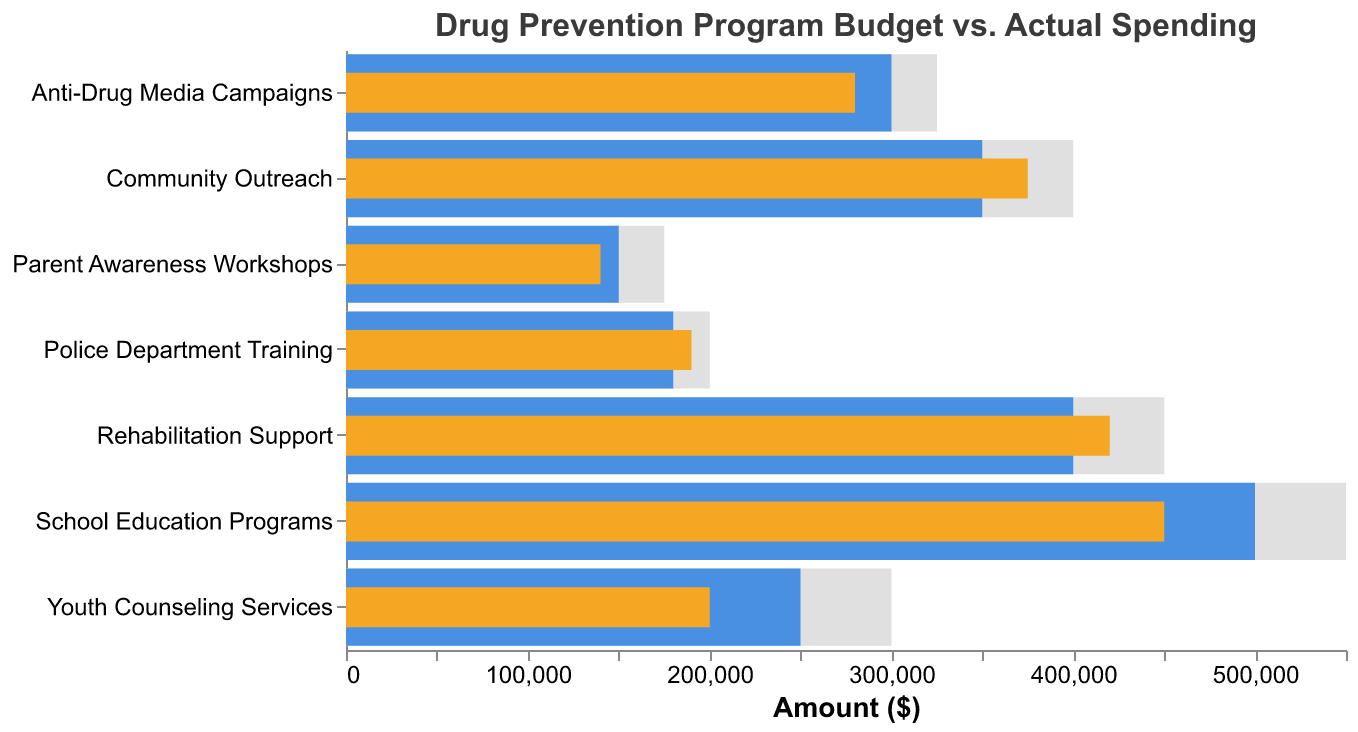How many initiatives are listed in the figure? There are a total of 7 categories listed in the data and each represents an initiative. You can count the different rows or categories along the y-axis.
Answer: 7 What is the title of the figure? The title is displayed at the top of the chart.
Answer: Drug Prevention Program Budget vs. Actual Spending Which initiative had the highest budgeted amount? The initiative with the highest budgeted amount among the listed categories is identified by looking at the "Budgeted ($)" bars for the largest value.
Answer: School Education Programs Did the Youth Counseling Services meet its target spending? To determine if the target was met, compare the actual spending amount to the target amount. For Youth Counseling Services, the actual spending is 200,000, and the target is 300,000, so the target was not met.
Answer: No Which initiative had actual spending that exceeded its budgeted amount? To find this, compare the actual spending bars to the budgeted bars for each initiative. Rehabilitation Support had actual spending of 420,000 compared to a budgeted amount of 400,000.
Answer: Rehabilitation Support What was the difference between budgeted and actual spending for Anti-Drug Media Campaigns? Subtract the actual spending from the budgeted amount for Anti-Drug Media Campaigns: 300,000 - 280,000 = 20,000.
Answer: 20,000 Which initiative had the largest gap between its budgeted and target spending? Calculate the difference between budgeted and target spending for each initiative and find the one with the largest gap. School Education Programs: 550,000 - 500,000 = 50,000.
Answer: School Education Programs Which initiative's actual spending most closely matched its target? Compare the actual spending to the target amount for each initiative and find the closest match. For Police Department Training, the actual spending is 190,000 and the target is 200,000, which is a difference of 10,000, the smallest gap.
Answer: Police Department Training What is the target spending for Parent Awareness Workshops? The target spending can be directly read from the tooltip or the bar representing the target value for Parent Awareness Workshops.
Answer: 175,000 How much more was spent on Community Outreach than was budgeted? Subtract the budgeted amount for Community Outreach from the actual spending: 375,000 - 350,000 = 25,000.
Answer: 25,000 